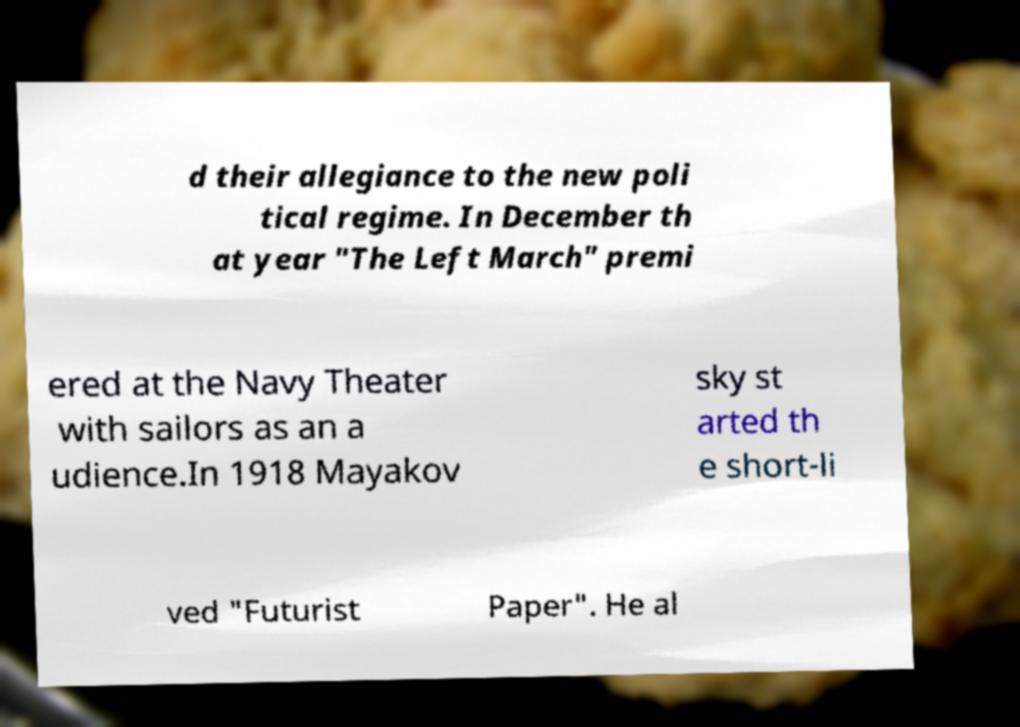For documentation purposes, I need the text within this image transcribed. Could you provide that? d their allegiance to the new poli tical regime. In December th at year "The Left March" premi ered at the Navy Theater with sailors as an a udience.In 1918 Mayakov sky st arted th e short-li ved "Futurist Paper". He al 